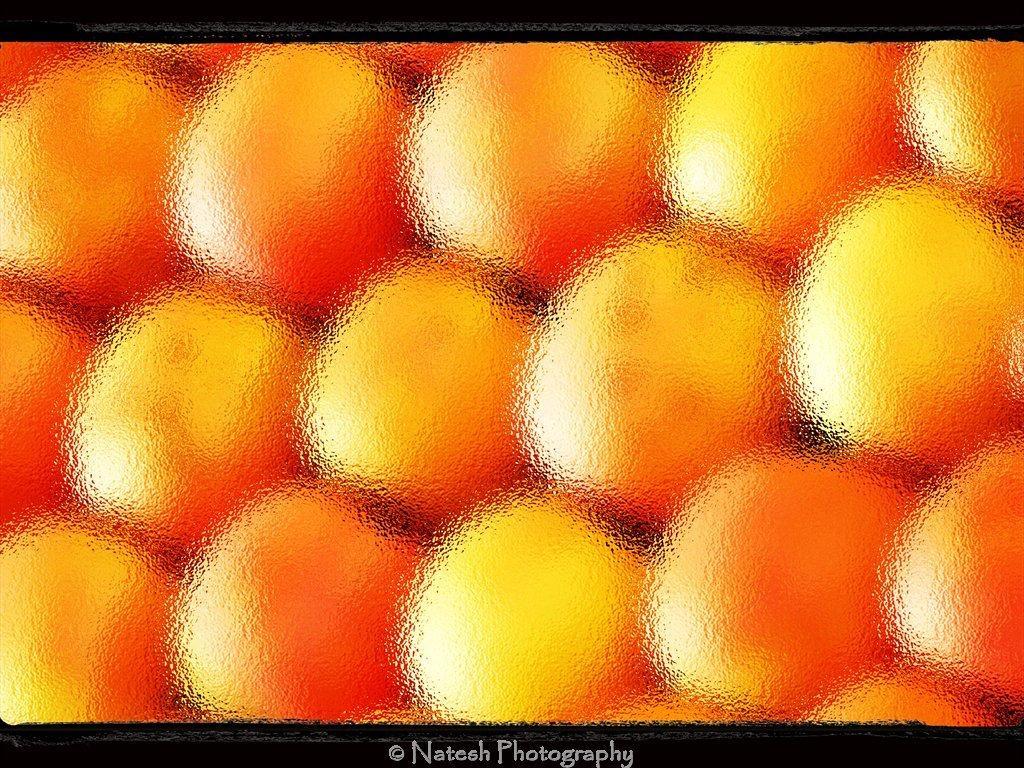How would you summarize this image in a sentence or two? In this image, it seems like oranges and it is blurred, at the bottom there is some text. 